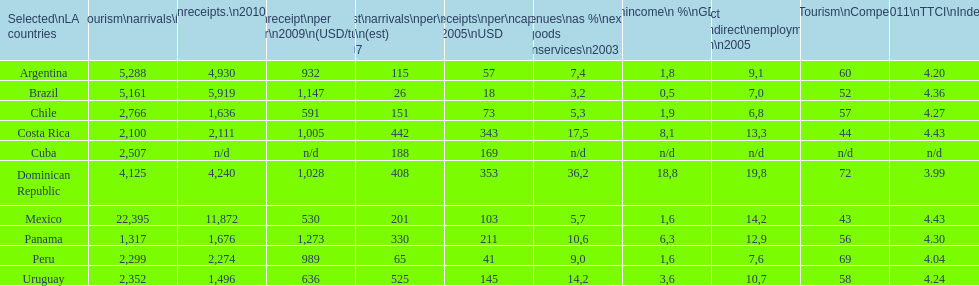What country ranks the best in most categories? Dominican Republic. 